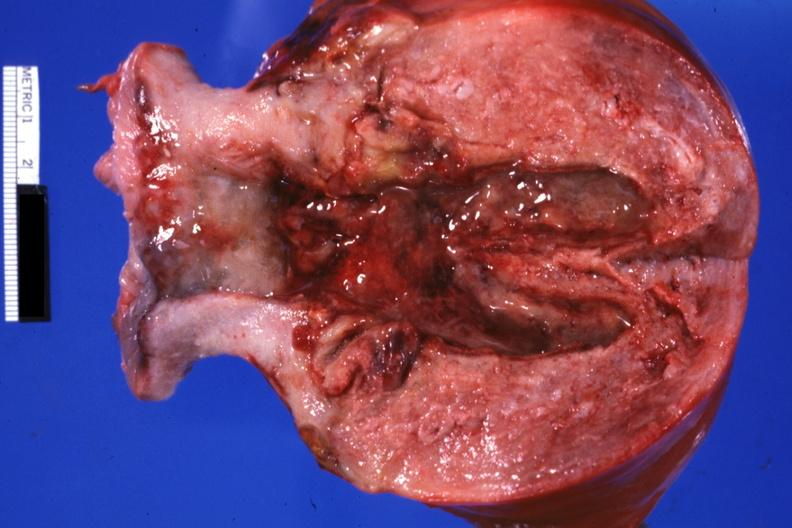s uterus present?
Answer the question using a single word or phrase. Yes 